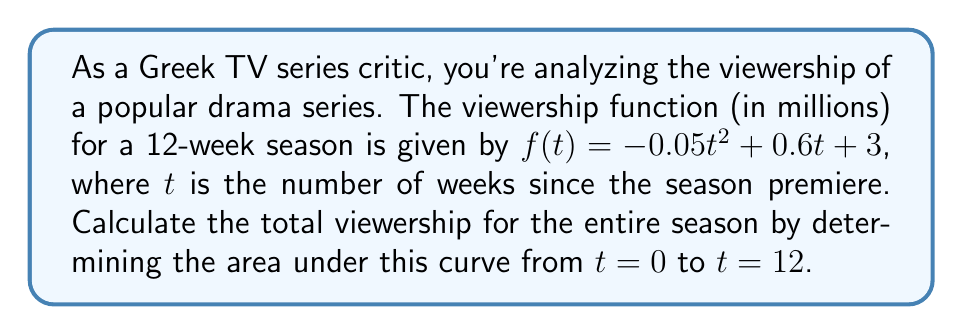Provide a solution to this math problem. To find the total viewership for the season, we need to calculate the definite integral of the viewership function from $t=0$ to $t=12$. 

1) The viewership function is $f(t) = -0.05t^2 + 0.6t + 3$

2) We need to integrate this function:
   $$\int_0^{12} (-0.05t^2 + 0.6t + 3) dt$$

3) Integrate each term:
   $$\left[-\frac{0.05t^3}{3} + 0.3t^2 + 3t\right]_0^{12}$$

4) Evaluate at the upper and lower bounds:
   $$\left[-\frac{0.05(12)^3}{3} + 0.3(12)^2 + 3(12)\right] - \left[-\frac{0.05(0)^3}{3} + 0.3(0)^2 + 3(0)\right]$$

5) Simplify:
   $$\left[-28.8 + 43.2 + 36\right] - [0]$$
   $$= 50.4$$

6) The result, 50.4, represents the total viewership in million-weeks. To interpret this, it means that over the 12-week season, the cumulative viewership is equivalent to 50.4 million people watching for one week.
Answer: 50.4 million-weeks 